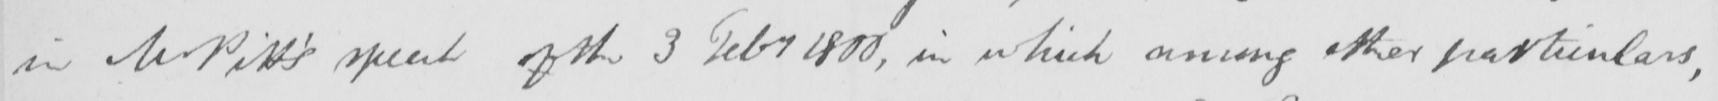What does this handwritten line say? in Mr Pitt ' s speech of the 3 Feby 1800 , in which among other particulars , 